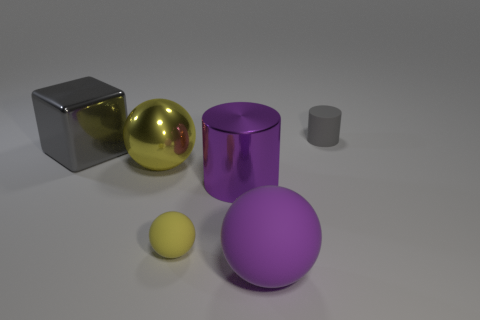Is the metallic cylinder the same color as the large rubber ball?
Give a very brief answer. Yes. What is the shape of the object that is the same color as the block?
Ensure brevity in your answer.  Cylinder. Is the shape of the small gray thing the same as the purple object that is behind the large purple matte thing?
Make the answer very short. Yes. Are there more big green shiny cubes than big gray metal blocks?
Keep it short and to the point. No. How many things are objects that are behind the large rubber thing or small things?
Provide a short and direct response. 5. Are the block and the tiny ball made of the same material?
Your answer should be very brief. No. The yellow metal thing that is the same shape as the purple matte object is what size?
Give a very brief answer. Large. There is a small thing that is to the left of the shiny cylinder; is it the same shape as the small thing that is behind the tiny yellow rubber thing?
Keep it short and to the point. No. Do the yellow rubber sphere and the cylinder to the left of the small gray cylinder have the same size?
Ensure brevity in your answer.  No. How many other objects are there of the same material as the large yellow sphere?
Keep it short and to the point. 2. 